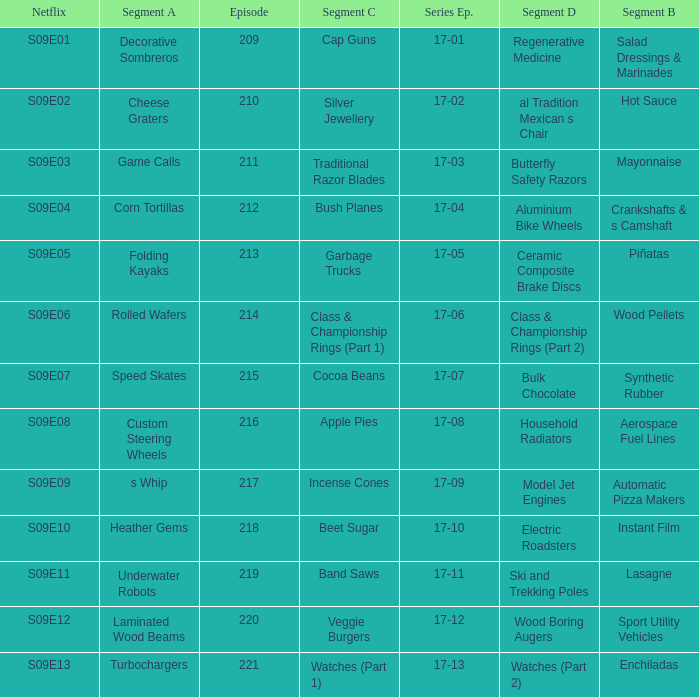Episode smaller than 210 had what segment c? Cap Guns. 